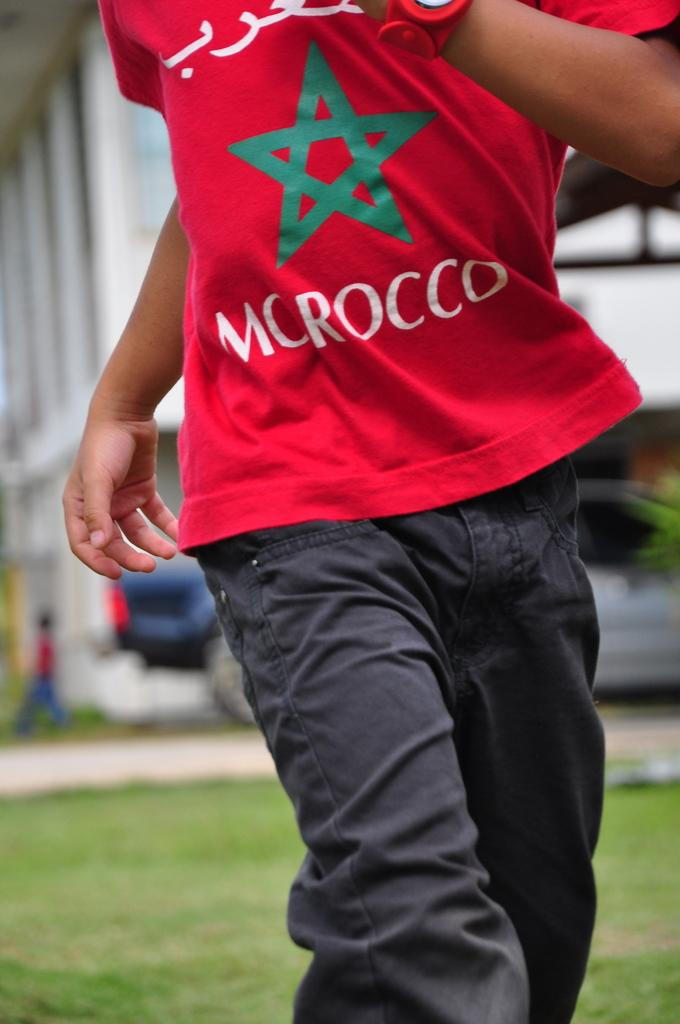<image>
Write a terse but informative summary of the picture. a person that has a shirt on that says Morocco 